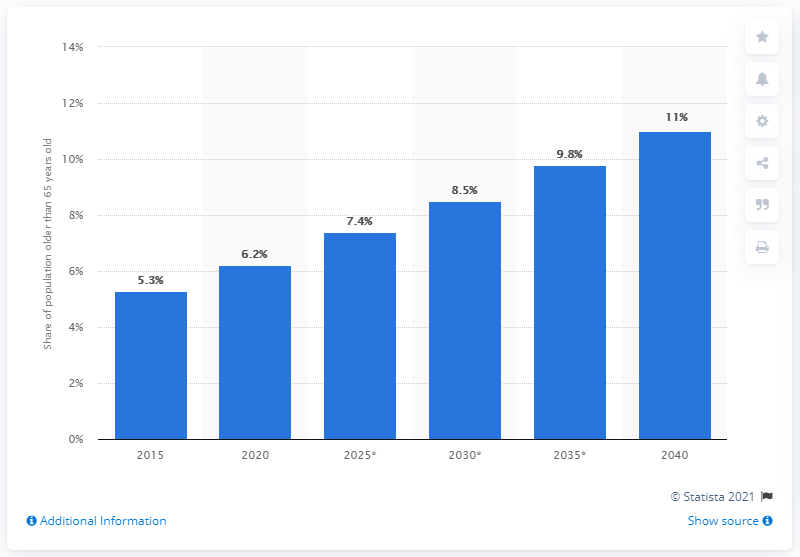Outline some significant characteristics in this image. In the chart, the years 2015, 2020, and 2025 are highlighted. It is observed that there is a gap of 5 years between these years. In 2020, the percentage of the population older than 65 in Burma was 6.2%. By 2040, it is projected that approximately 11% of the population will be 65 years and older. Assuming a growth rate of 5.3% will result in a population of 1,00,000 in 2040, what will be the population of 11% growth in 207547? 